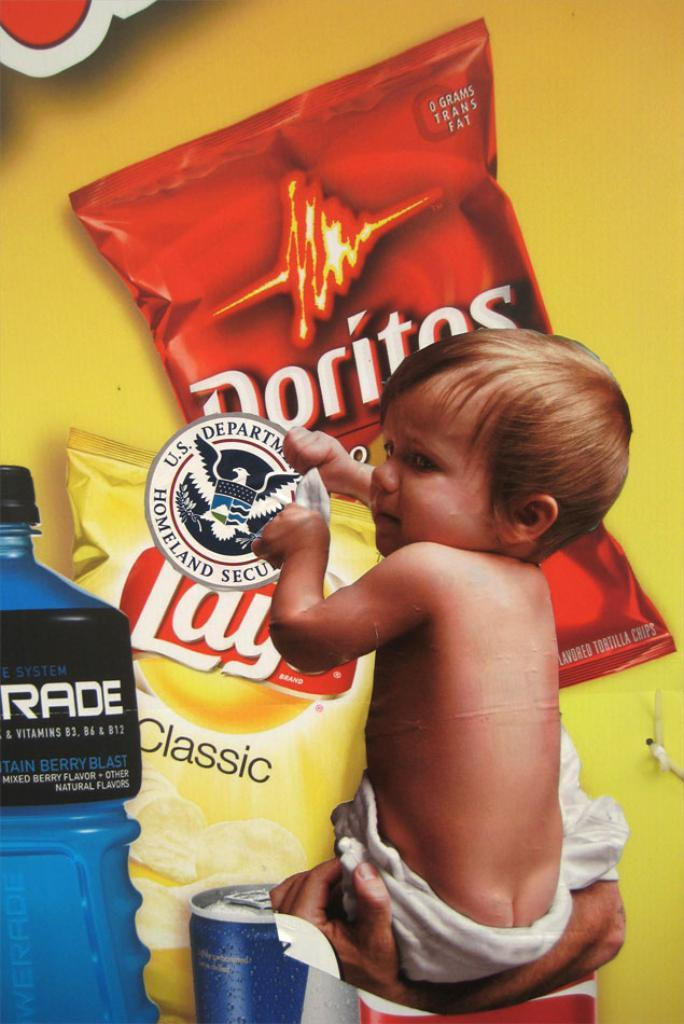What is the person in the image doing with the boy? The person is holding a boy in the image. What is the boy holding in his hand? The boy is holding a circular object in his hand. What type of snacks can be seen in the image? There are Lays chips packets and Doritos chips packets in the image. What other items are present in the image? There is a bottle and a can in the image. What type of rifle can be seen in the image? There is no rifle present in the image. What is the range of the jar in the image? There is no jar present in the image, so it is not possible to determine its range. 